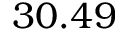Convert formula to latex. <formula><loc_0><loc_0><loc_500><loc_500>3 0 . 4 9</formula> 